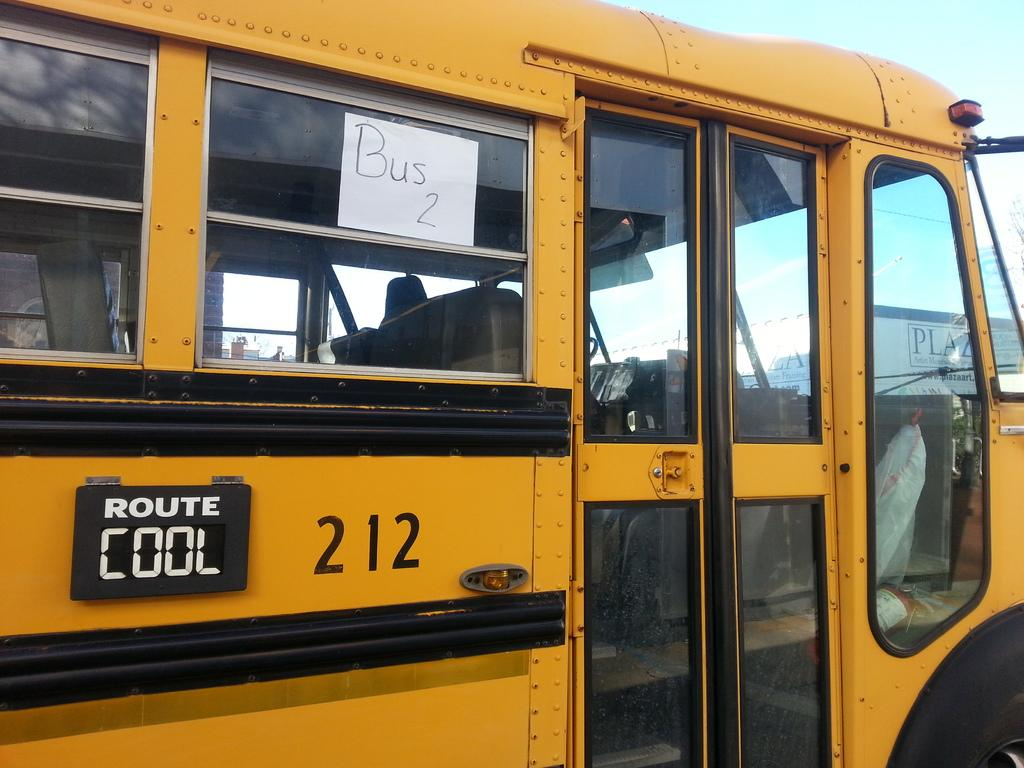<image>
Write a terse but informative summary of the picture. A paper sign in the window of the bus reads Bus 2. 